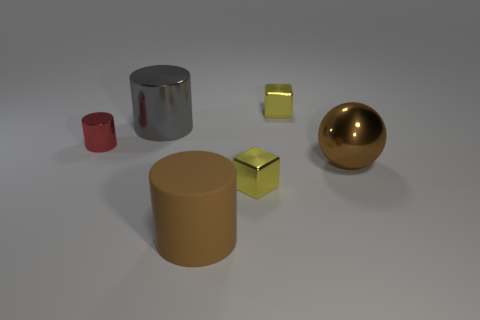There is a object to the right of the small yellow cube that is behind the tiny red metallic cylinder; what shape is it?
Your answer should be very brief. Sphere. Is there any other thing that has the same shape as the big brown metal thing?
Keep it short and to the point. No. There is another large object that is the same shape as the big gray object; what is its color?
Your answer should be very brief. Brown. There is a large shiny cylinder; is its color the same as the block in front of the tiny metal cylinder?
Your answer should be compact. No. The shiny object that is left of the shiny ball and in front of the red shiny thing has what shape?
Offer a very short reply. Cube. Are there fewer tiny cyan metal objects than gray metal things?
Give a very brief answer. Yes. Are any tiny purple rubber things visible?
Ensure brevity in your answer.  No. How many other objects are the same size as the matte cylinder?
Make the answer very short. 2. Does the ball have the same material as the large cylinder that is to the left of the large brown cylinder?
Give a very brief answer. Yes. Are there the same number of small cylinders that are behind the big gray metallic cylinder and gray metal cylinders in front of the large matte object?
Offer a very short reply. Yes. 